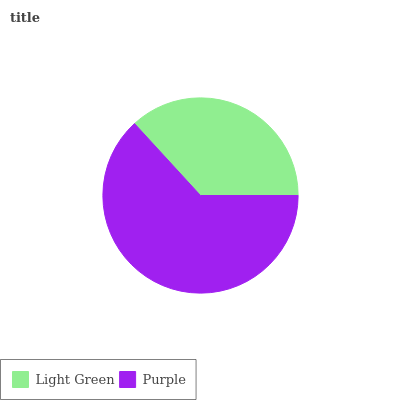Is Light Green the minimum?
Answer yes or no. Yes. Is Purple the maximum?
Answer yes or no. Yes. Is Purple the minimum?
Answer yes or no. No. Is Purple greater than Light Green?
Answer yes or no. Yes. Is Light Green less than Purple?
Answer yes or no. Yes. Is Light Green greater than Purple?
Answer yes or no. No. Is Purple less than Light Green?
Answer yes or no. No. Is Purple the high median?
Answer yes or no. Yes. Is Light Green the low median?
Answer yes or no. Yes. Is Light Green the high median?
Answer yes or no. No. Is Purple the low median?
Answer yes or no. No. 